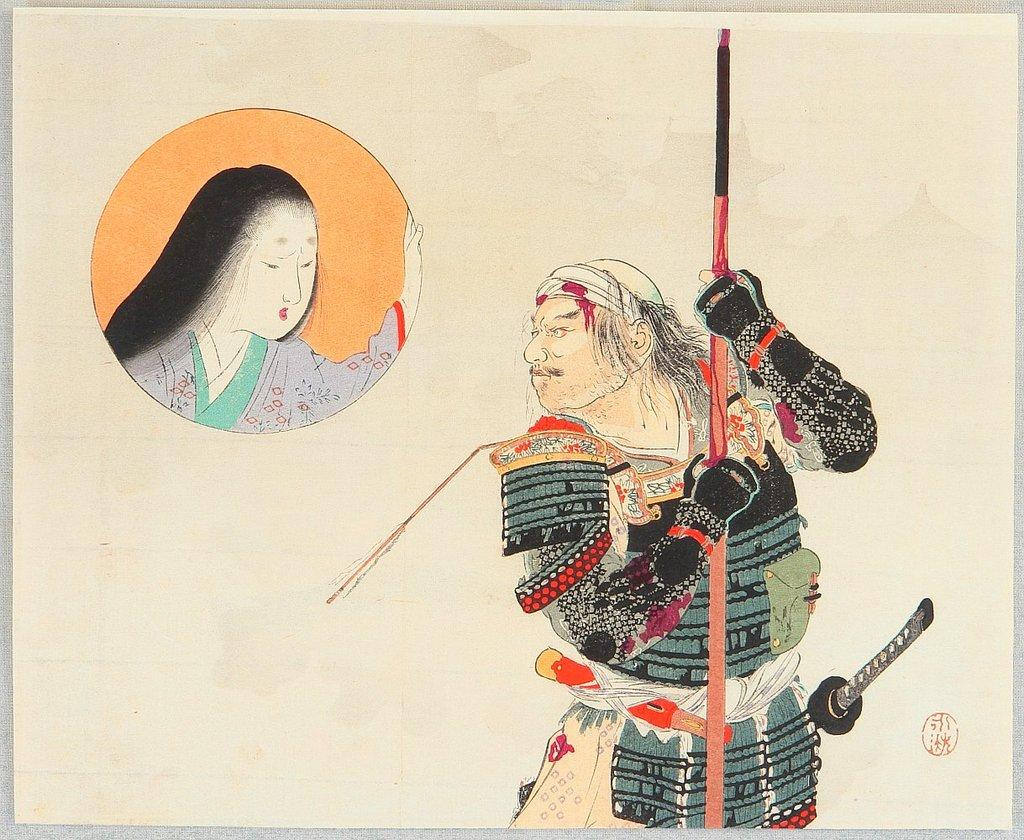What is the main subject of the image? The main subject of the image is a painting. What is depicted in the painting? The painting depicts two persons. What is one of the persons holding in the painting? One of the persons is holding a stick. Is the painting in the image wearing a scarf? There is no person in the image wearing a scarf, as the main subject of the image is a painting that depicts two persons. 